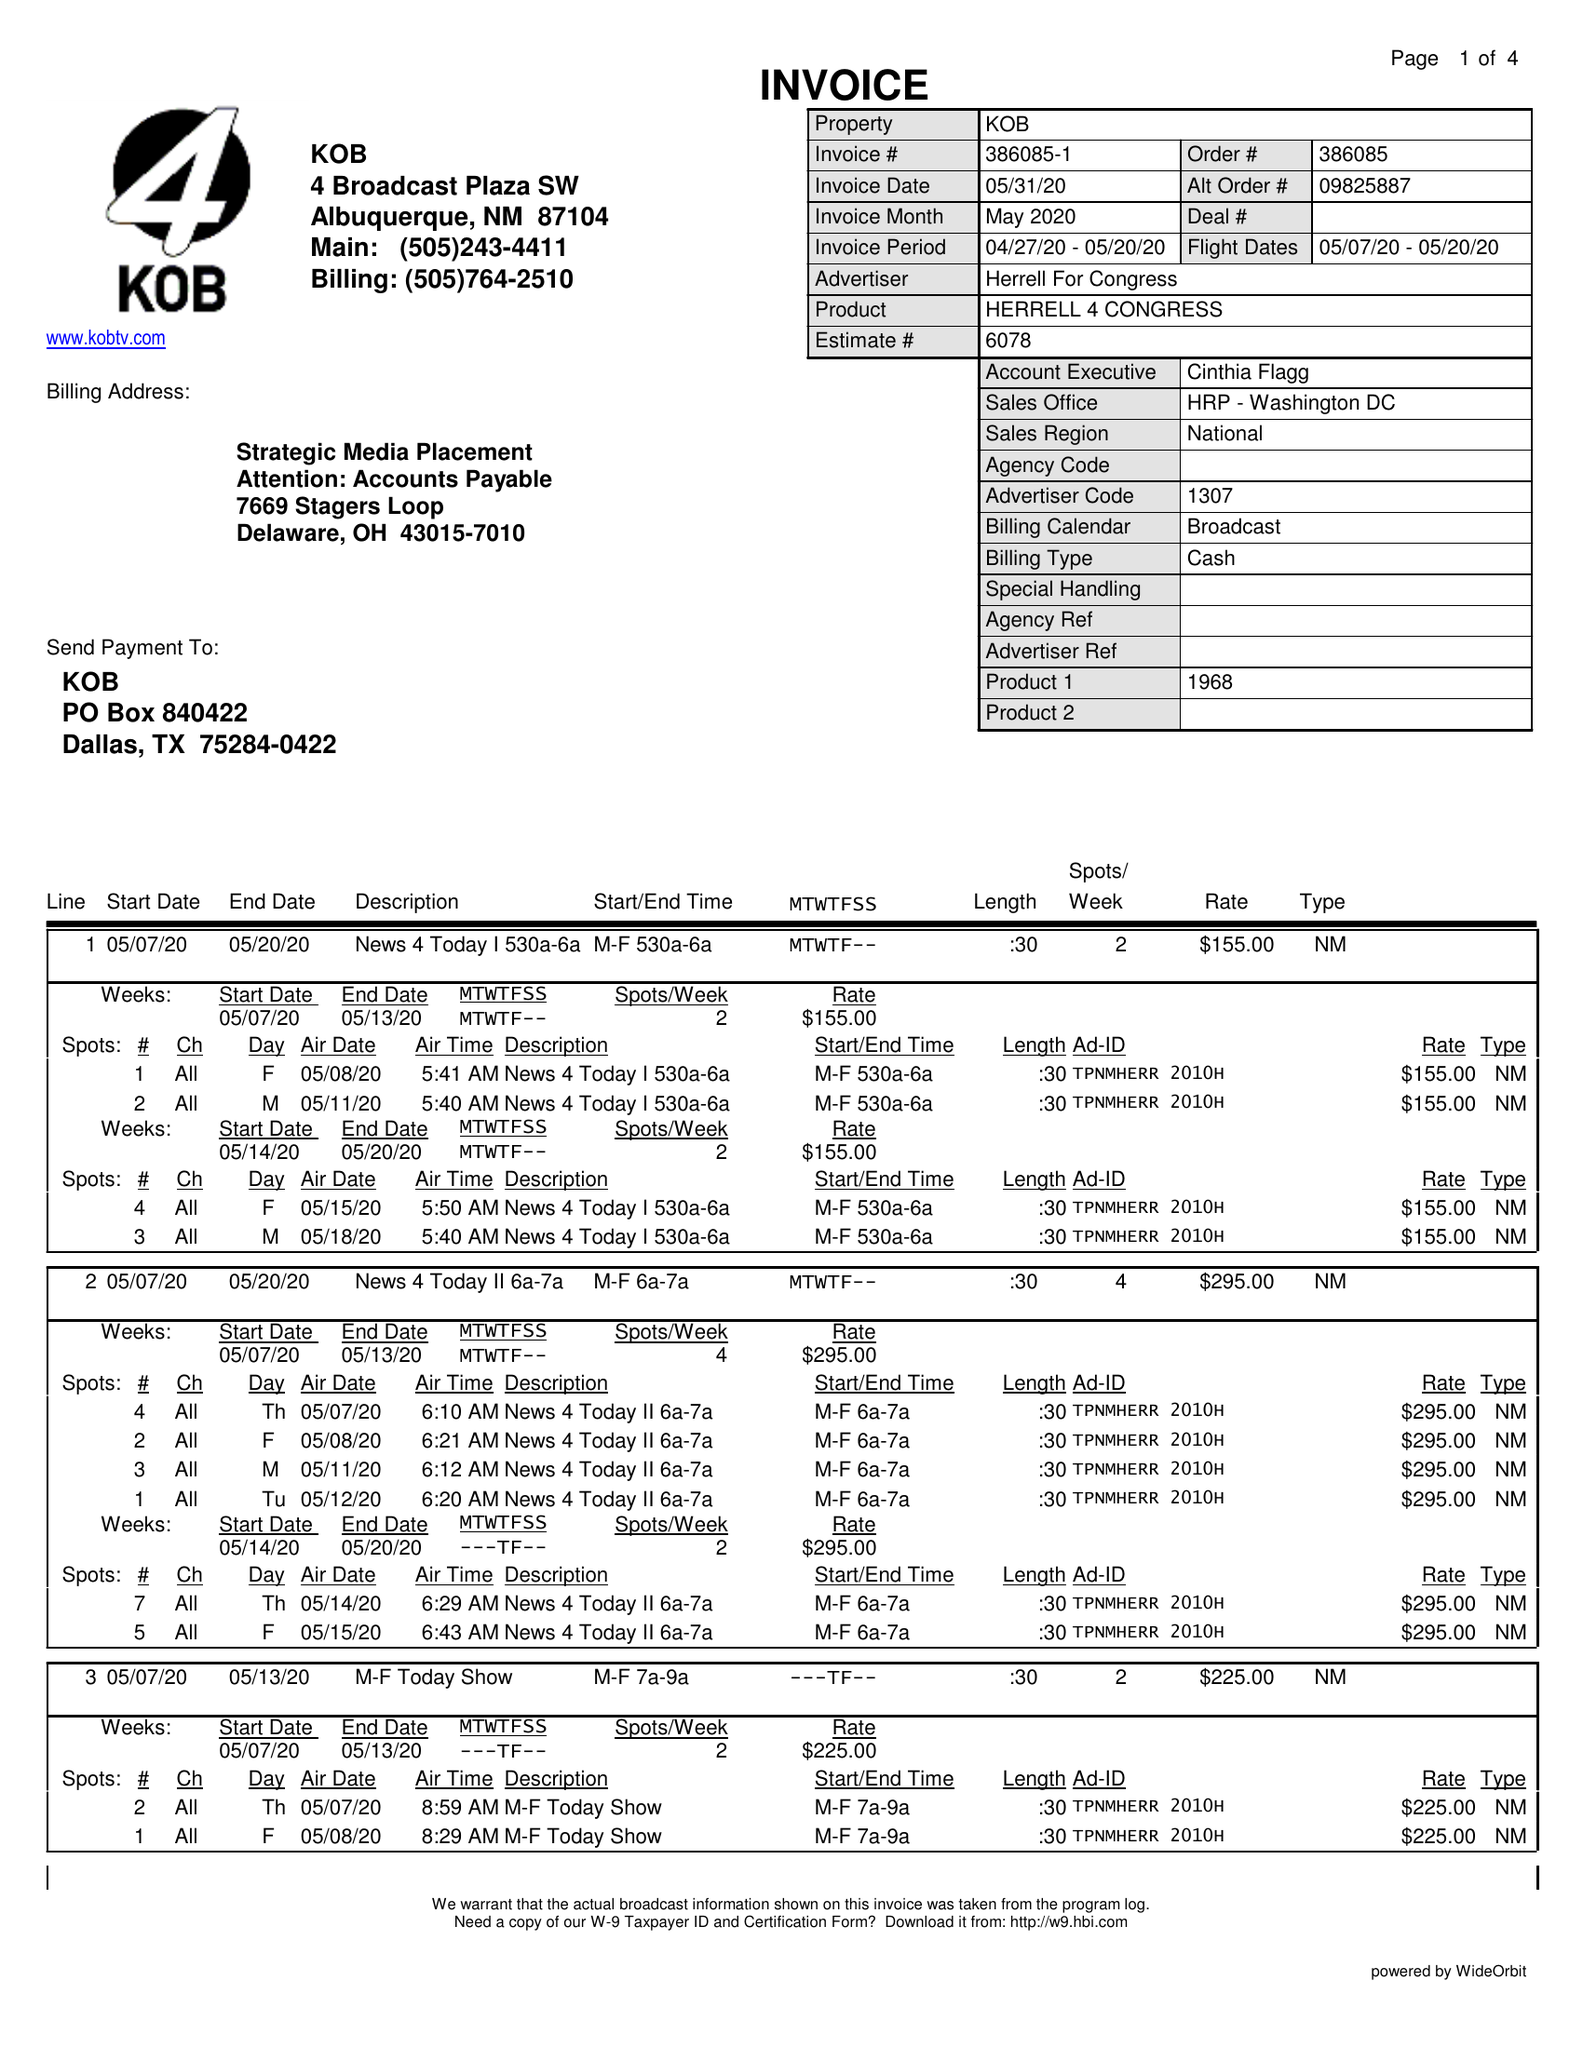What is the value for the flight_from?
Answer the question using a single word or phrase. 05/07/20 